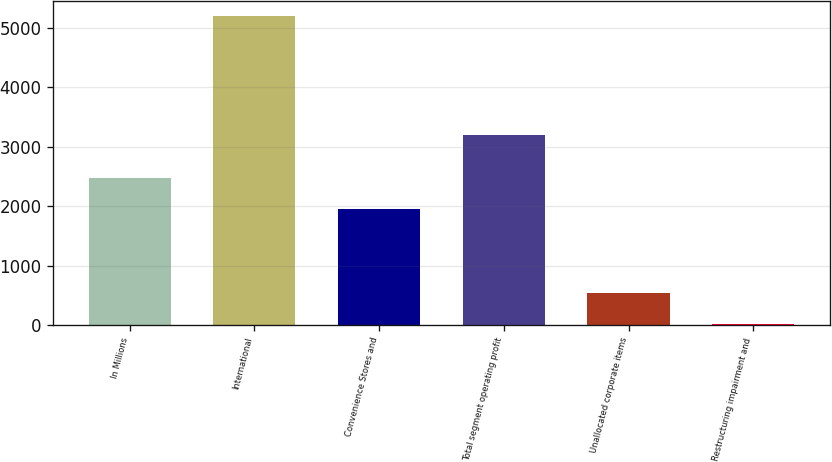Convert chart. <chart><loc_0><loc_0><loc_500><loc_500><bar_chart><fcel>In Millions<fcel>International<fcel>Convenience Stores and<fcel>Total segment operating profit<fcel>Unallocated corporate items<fcel>Restructuring impairment and<nl><fcel>2477.04<fcel>5200.2<fcel>1959<fcel>3197.7<fcel>537.84<fcel>19.8<nl></chart> 